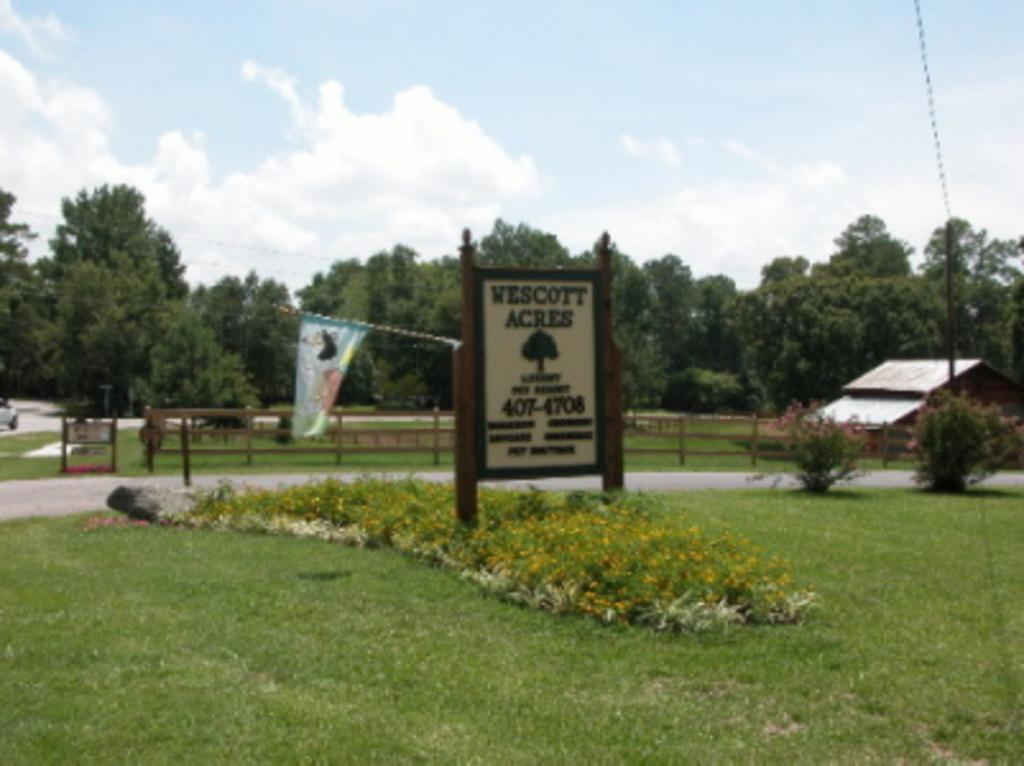What type of vegetation can be seen in the image? There is grass in the image. What object is present in the image that might be used for displaying information or messages? There is a board in the image. What can be seen flying or waving in the image? There is a flag in the image. What type of barrier is visible in the image? There is a fence in the image. What structure is located on the left side of the image? There is a shed on the left side of the image. What type of natural feature is visible at the back of the image? There are trees at the back of the image. What type of bubble can be seen floating in the image? There is no bubble present in the image. What type of hook is attached to the shed in the image? There is no hook attached to the shed in the image. 